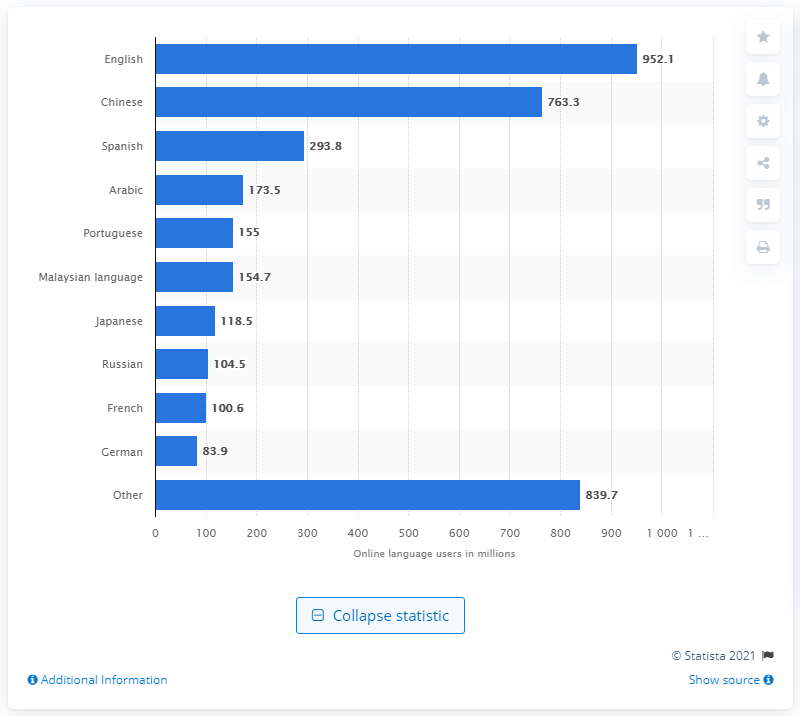What was the most popular language online as of March 2017? As of March 2017, the most popular language online was English, with approximately 952.1 million users leading by a substantial margin over other languages like Chinese and Spanish. This data highlights the global dominance of English in the digital realm, relevant for both cultural and business contexts. 